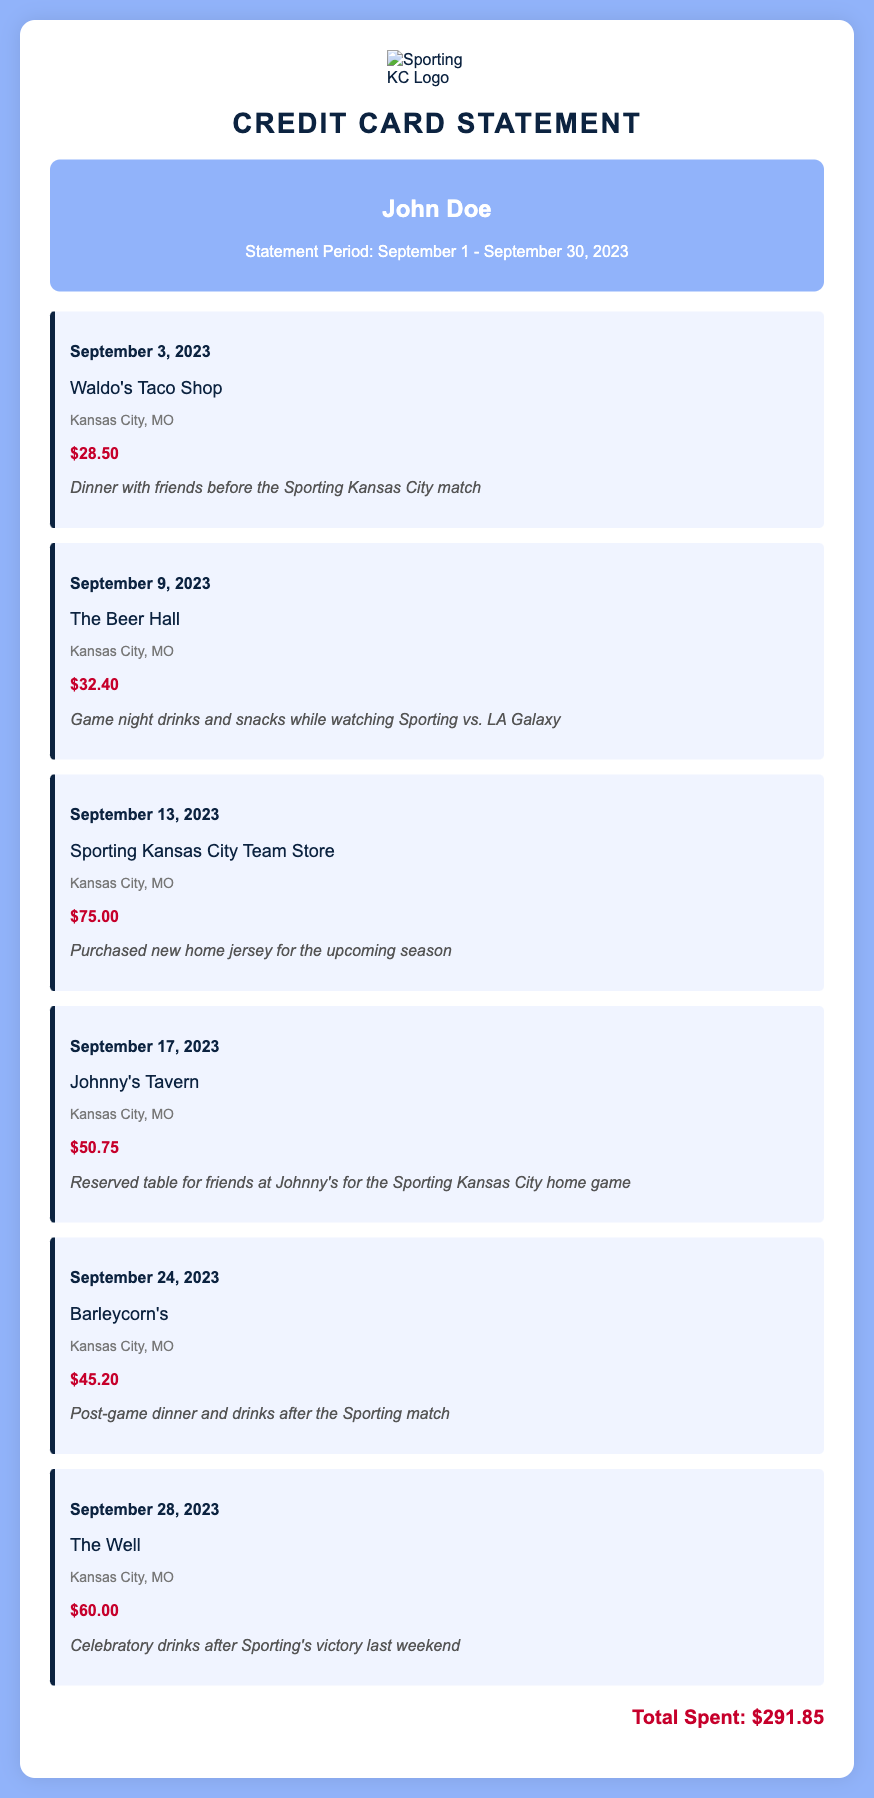What is the name of the first merchant? The first transaction is with Waldo's Taco Shop on September 3, 2023.
Answer: Waldo's Taco Shop What was the total amount spent? The total section at the bottom of the statement shows the overall expenditure during the period.
Answer: $291.85 How much was spent on Sporting Kansas City merchandise? There is a specific transaction that details the purchase of merchandise at the Sporting Kansas City Team Store, which is $75.00.
Answer: $75.00 On what date was dinner before a Sporting Kansas City match purchased? The transaction describes dinner with friends before the match on September 3, 2023.
Answer: September 3, 2023 Which bar was mentioned for post-game dinner and drinks? The transaction list indicates Barleycorn's was the location for post-game dinner and drinks after the match.
Answer: Barleycorn's How much did the reserved table at Johnny's Tavern cost? The transaction shows the amount for the reserved table at Johnny's Tavern was $50.75.
Answer: $50.75 What type of transaction occurred on September 28, 2023? The description for the transaction on this date states celebratory drinks were purchased after a match.
Answer: Celebratory drinks What is the location of The Beer Hall? The location specified in the transaction detail indicates that The Beer Hall is in Kansas City, MO.
Answer: Kansas City, MO How many transactions were made in total? Counting each transaction listed in the document provides the total number of purchases during the statement period.
Answer: 6 